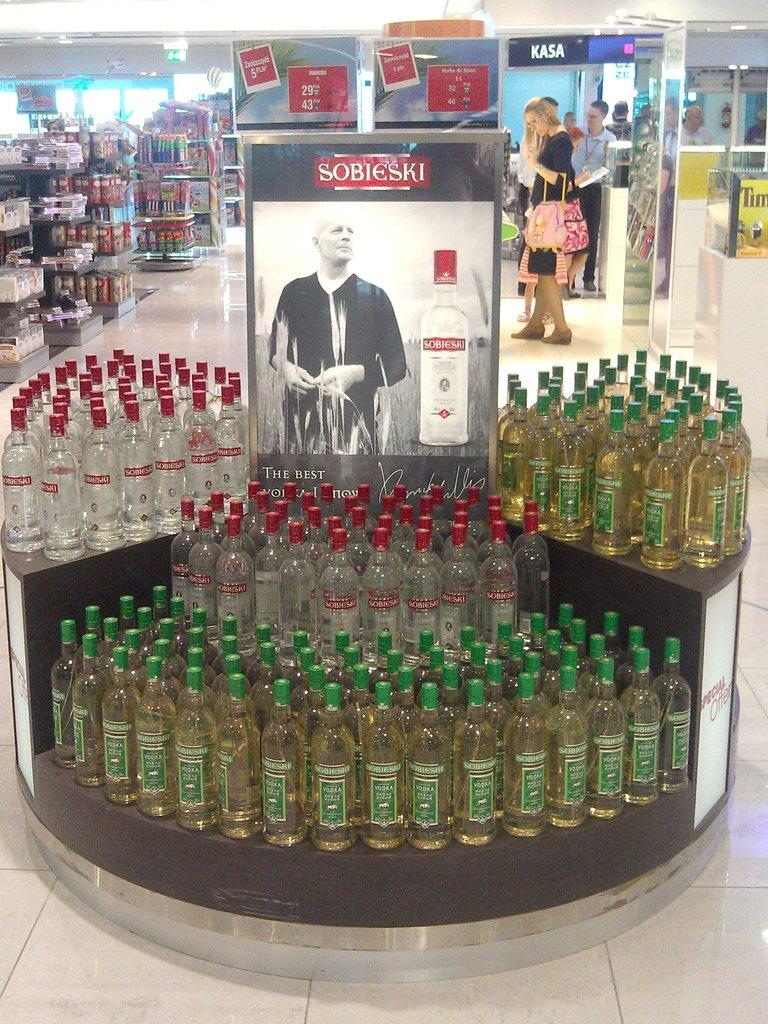<image>
Write a terse but informative summary of the picture. Sobieski liquor display in the middle of a store. 